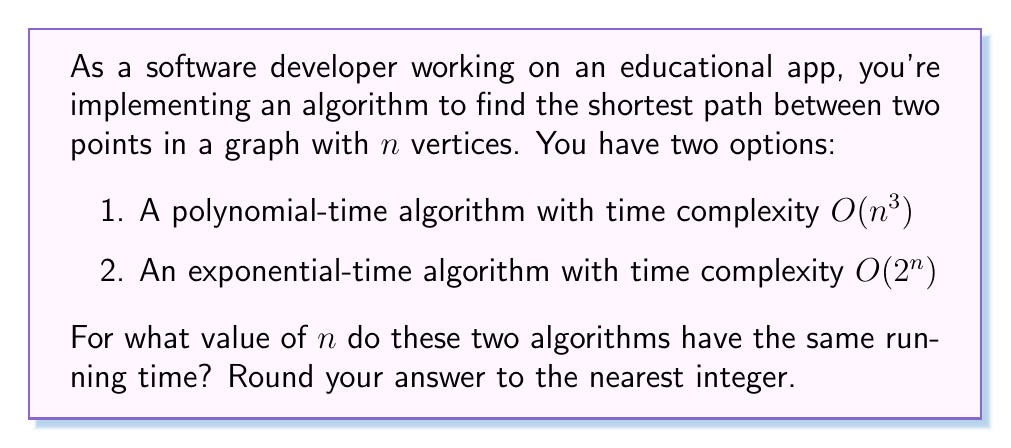Solve this math problem. To find the value of $n$ where both algorithms have the same running time, we need to set their time complexities equal to each other and solve for $n$:

$$O(n^3) = O(2^n)$$

Removing the big O notation, we can write this as an equation:

$$n^3 = 2^n$$

Taking the logarithm (base 2) of both sides:

$$\log_2(n^3) = \log_2(2^n)$$

Using the logarithm property $\log_a(x^y) = y\log_a(x)$:

$$3\log_2(n) = n$$

This equation cannot be solved algebraically, so we need to use numerical methods or graphing to find the solution. Using a graphing calculator or computer algebra system, we can find that the solution is approximately:

$$n \approx 9.98$$

Rounding to the nearest integer gives us 10.

This means that for $n < 10$, the polynomial-time algorithm ($O(n^3)$) is faster, and for $n > 10$, the exponential-time algorithm ($O(2^n)$) is slower. At $n = 10$, they have approximately the same running time.

This example illustrates why polynomial-time algorithms are generally preferred over exponential-time algorithms for large inputs, as they scale much better as $n$ increases.
Answer: 10 